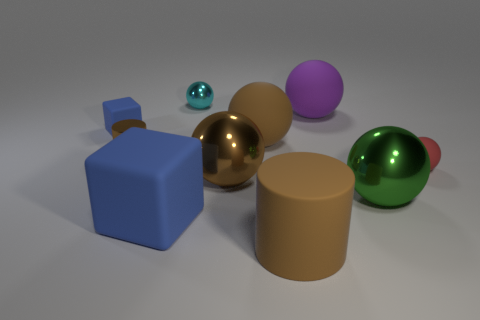Subtract all brown spheres. How many spheres are left? 4 Subtract all large brown matte balls. How many balls are left? 5 Subtract all gray balls. Subtract all red cubes. How many balls are left? 6 Subtract all cylinders. How many objects are left? 8 Subtract all large green balls. Subtract all small metal things. How many objects are left? 7 Add 6 rubber cylinders. How many rubber cylinders are left? 7 Add 4 cyan things. How many cyan things exist? 5 Subtract 0 gray balls. How many objects are left? 10 